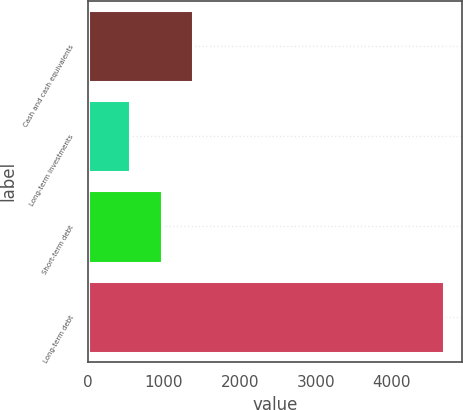Convert chart to OTSL. <chart><loc_0><loc_0><loc_500><loc_500><bar_chart><fcel>Cash and cash equivalents<fcel>Long-term investments<fcel>Short-term debt<fcel>Long-term debt<nl><fcel>1384.6<fcel>558<fcel>971.3<fcel>4691<nl></chart> 